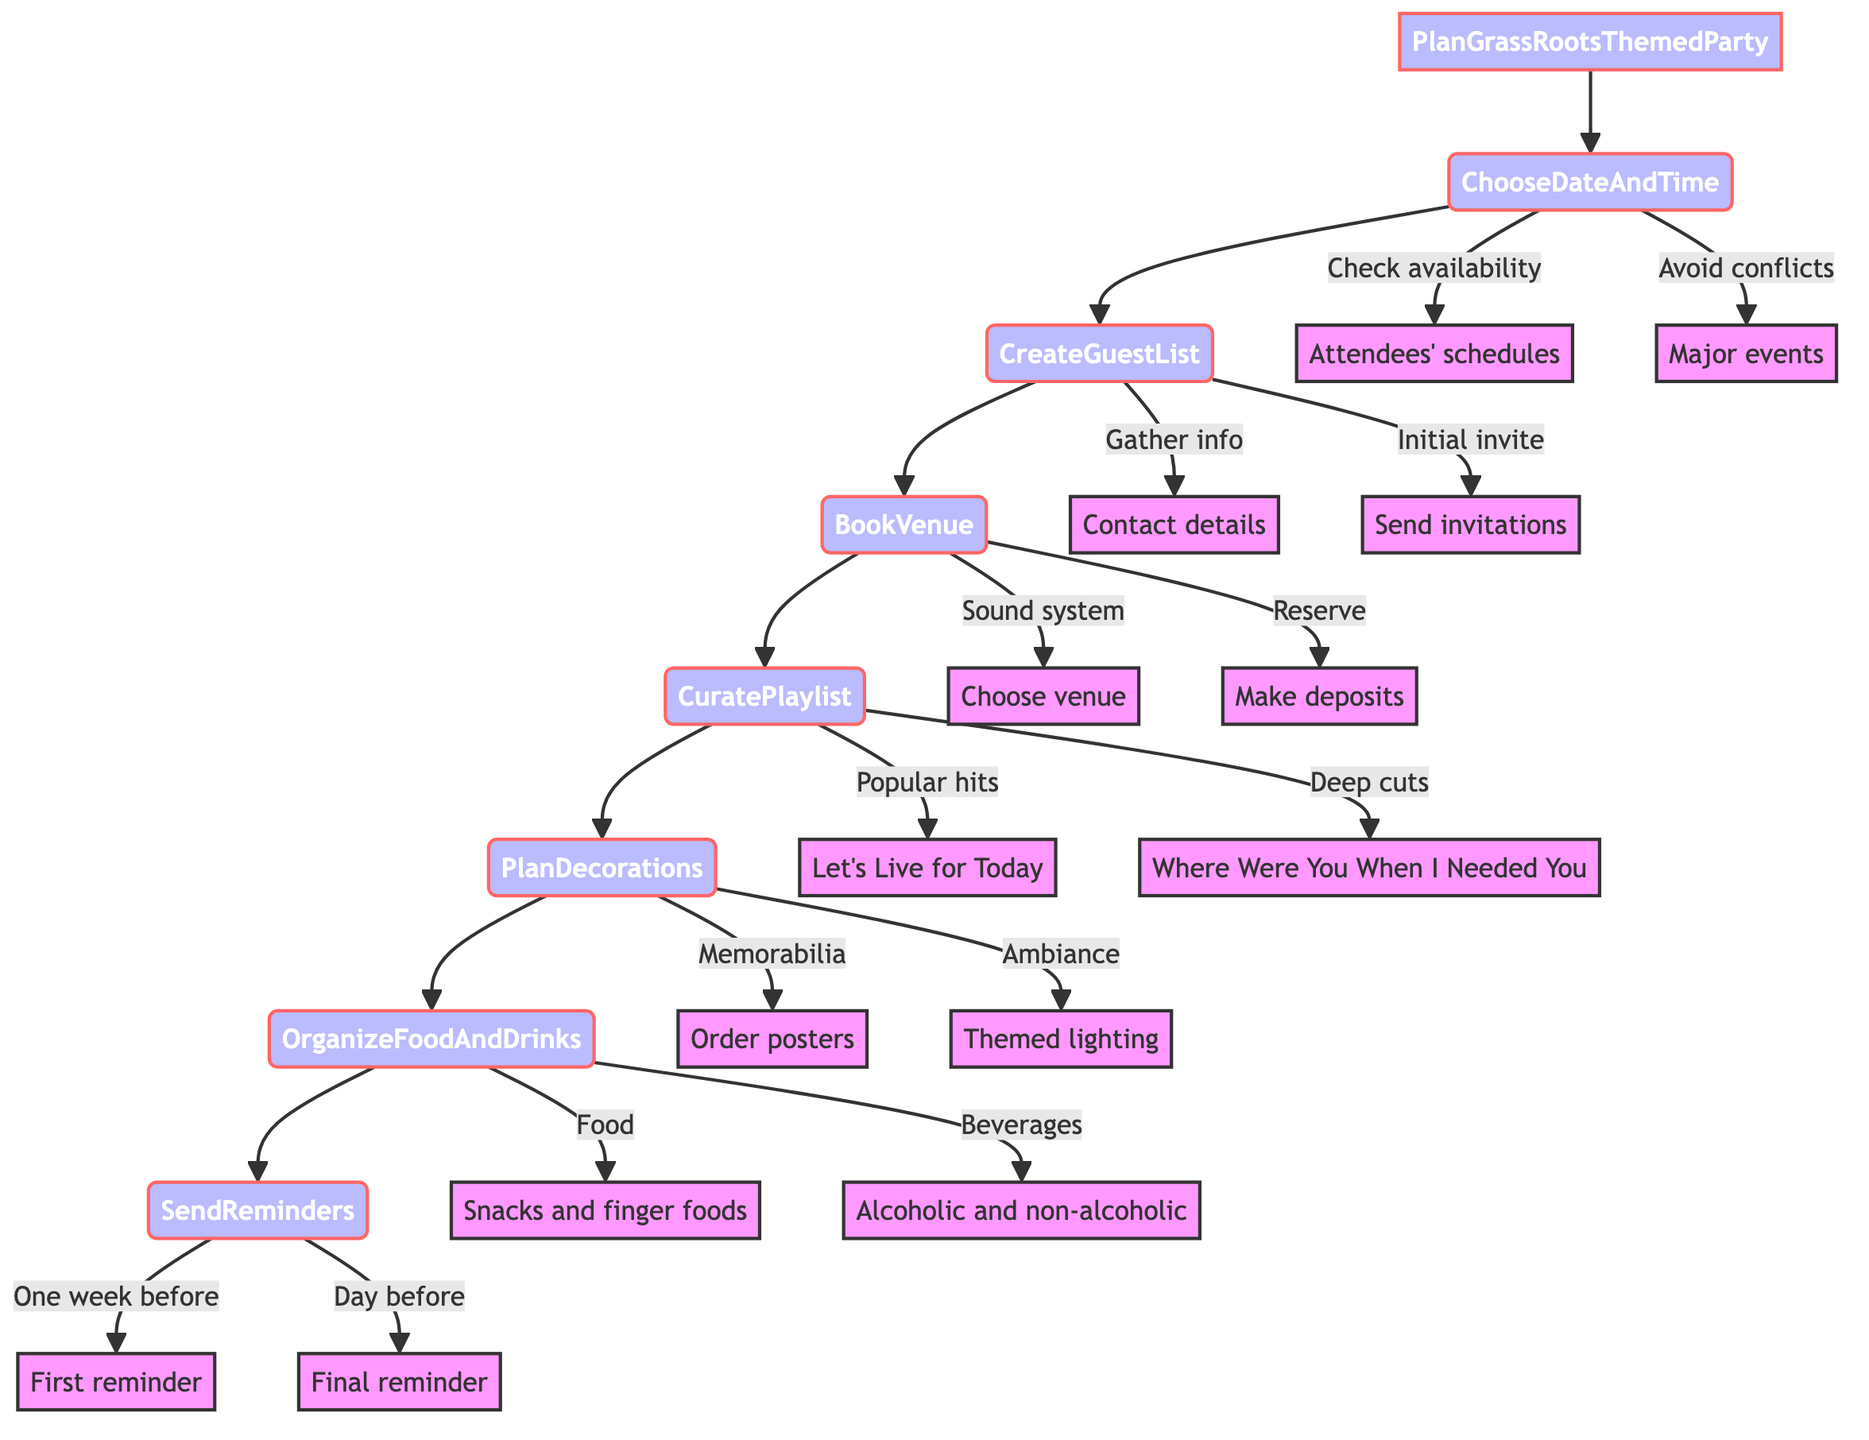What is the first step in planning the party? The first step in the flowchart is "ChooseDateAndTime." It is directly connected to the starting point of the diagram, indicating it as the initial action for planning the Grass Roots-themed party.
Answer: ChooseDateAndTime How many main steps are involved in planning the party? The diagram shows a total of seven main steps leading from "PlanGrassRootsThemedParty" to "SendReminders." By counting each step sequentially, we find there are seven.
Answer: 7 What step involves checking attendees' availability? The actions outlined under "ChooseDateAndTime" include checking attendees' availability. This step directly details one of the actions required during this phase of party planning.
Answer: ChooseDateAndTime What is included in the curated playlist? According to the flowchart, the curated playlist must include popular hits like "Let's Live for Today" and lesser-known tracks like "Where Were You When I Needed You." The query specifically points out these items listed in the "CuratePlaylist" step.
Answer: "Let's Live for Today", "Where Were You When I Needed You" What needs to be ordered for decorations? Under the "PlanDecorations" step, it states that band posters and memorabilia should be ordered. Thus, the focus is on these items to create a suitable atmosphere for the party.
Answer: Band posters and memorabilia How many reminders should be sent before the party? The flowchart specifies two reminders: one week before and one day before the party. By analyzing the "SendReminders" step, we determine the count of reminders as two.
Answer: 2 What must be done in the "OrganizeFoodAndDrinks" step? This step includes planning a menu that offers snacks and drinks. Specifically, it emphasizes preparing refreshments, combining both food items and beverages for the guests.
Answer: Plan a menu with snacks and drinks What are the two considerations in booking the venue? The "BookVenue" step outlines two considerations: choosing a venue with a good sound system and making necessary deposits. This step emphasizes these key actions for venue selection and reservation.
Answer: Good sound system, make deposits What action involves sending an invitation? Under "CreateGuestList," the action of sending out initial invitations is specified, showing this as part of the process for compiling the guest list for the party.
Answer: Send invitations 